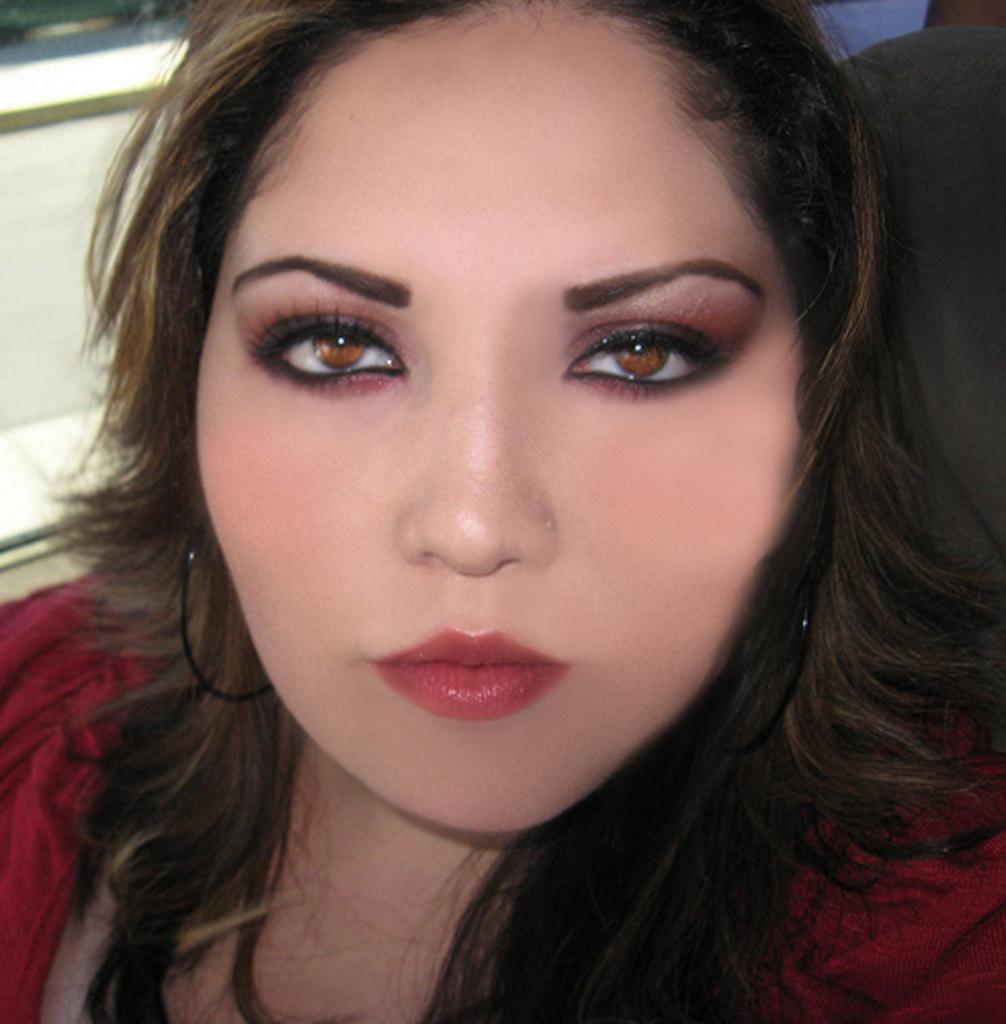What color is the jacket that the woman is wearing in the image? The woman is wearing a maroon jacket. What is the woman doing in the image? The woman is posing for a photo. What can be seen behind the woman in the image? There is a black chair behind the woman. What is the color of the wall on the left side of the image? There is a white wall on the left side of the image. Is there a bomb hidden behind the white wall in the image? No, there is no bomb present in the image. 